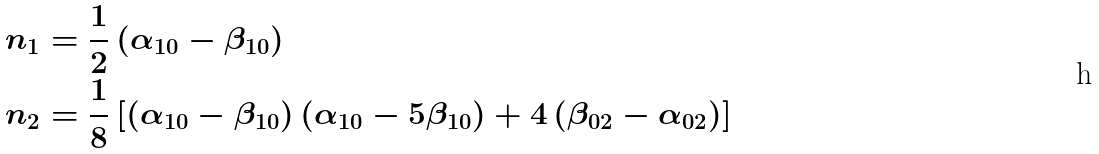<formula> <loc_0><loc_0><loc_500><loc_500>n _ { 1 } & = \frac { 1 } { 2 } \left ( \alpha _ { 1 0 } - \beta _ { 1 0 } \right ) \\ n _ { 2 } & = \frac { 1 } { 8 } \left [ \left ( \alpha _ { 1 0 } - \beta _ { 1 0 } \right ) \left ( \alpha _ { 1 0 } - 5 \beta _ { 1 0 } \right ) + 4 \left ( \beta _ { 0 2 } - \alpha _ { 0 2 } \right ) \right ]</formula> 